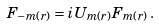Convert formula to latex. <formula><loc_0><loc_0><loc_500><loc_500>F _ { - m ( r ) } = i U _ { m ( r ) } F _ { m ( r ) } \, .</formula> 